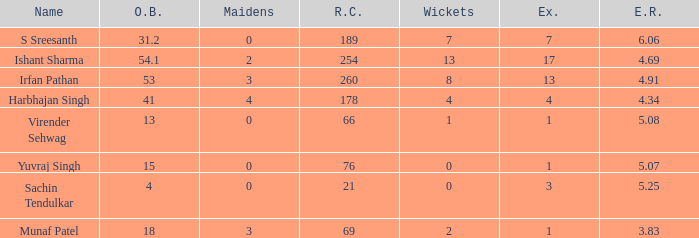Name the total number of wickets being yuvraj singh 1.0. 